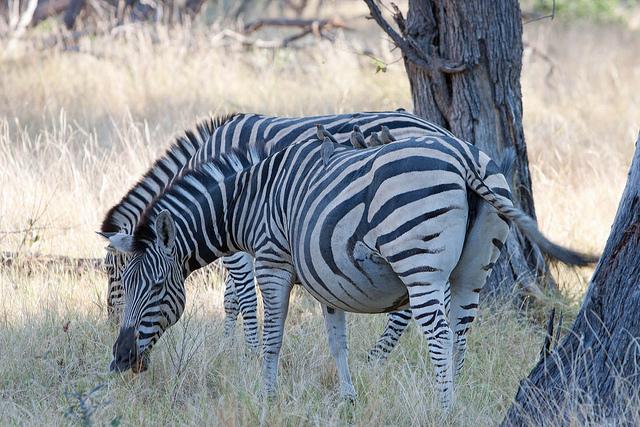What is sitting on the zebras back?
Write a very short answer. Birds. What type of animal is this?
Quick response, please. Zebra. Which animal is at the front?
Be succinct. Zebra. What are the zebras eating?
Keep it brief. Grass. 